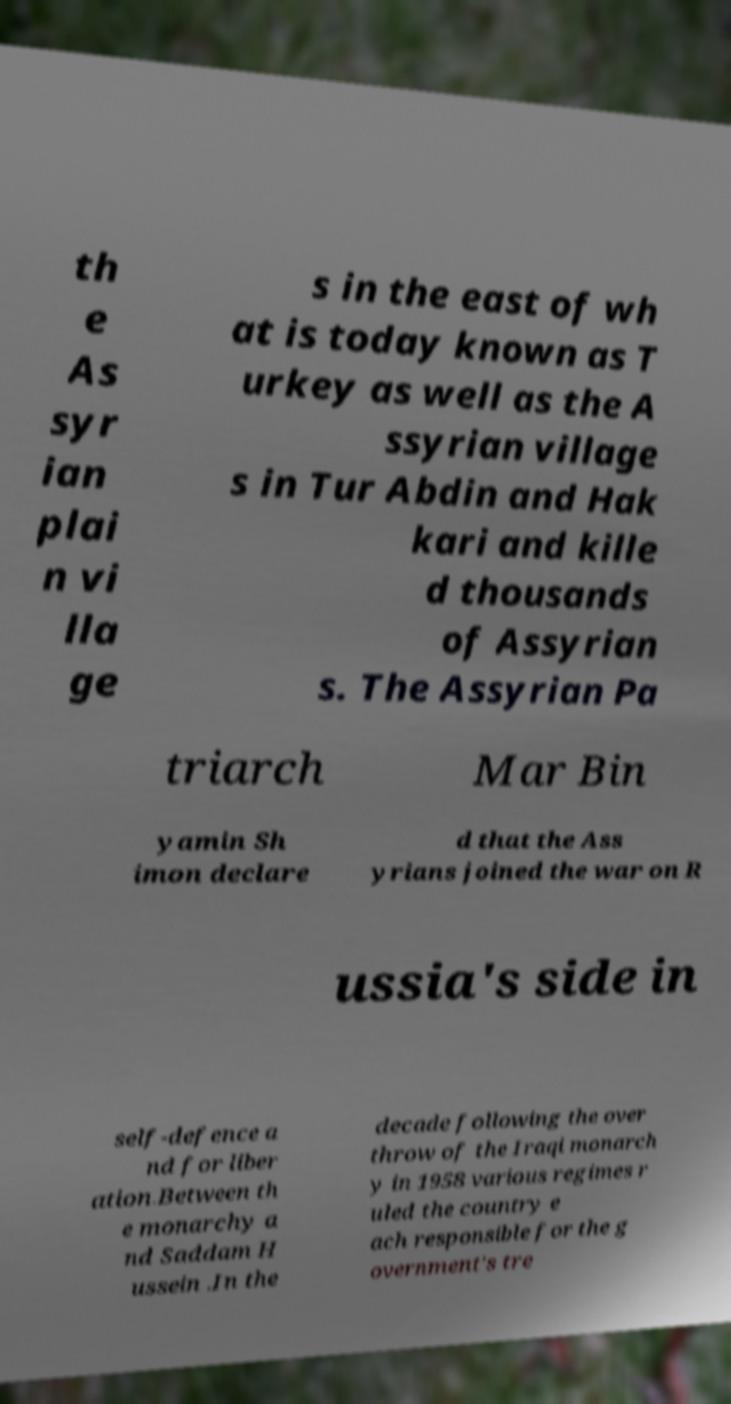Please read and relay the text visible in this image. What does it say? th e As syr ian plai n vi lla ge s in the east of wh at is today known as T urkey as well as the A ssyrian village s in Tur Abdin and Hak kari and kille d thousands of Assyrian s. The Assyrian Pa triarch Mar Bin yamin Sh imon declare d that the Ass yrians joined the war on R ussia's side in self-defence a nd for liber ation.Between th e monarchy a nd Saddam H ussein .In the decade following the over throw of the Iraqi monarch y in 1958 various regimes r uled the country e ach responsible for the g overnment's tre 